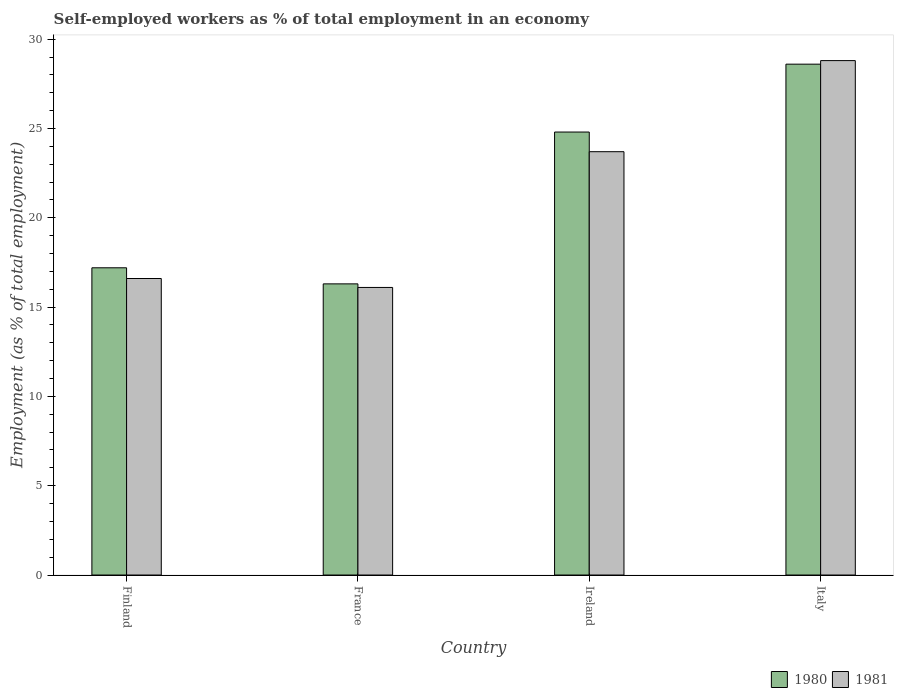How many bars are there on the 2nd tick from the left?
Make the answer very short. 2. How many bars are there on the 1st tick from the right?
Your response must be concise. 2. What is the label of the 3rd group of bars from the left?
Provide a short and direct response. Ireland. In how many cases, is the number of bars for a given country not equal to the number of legend labels?
Provide a succinct answer. 0. What is the percentage of self-employed workers in 1980 in Italy?
Make the answer very short. 28.6. Across all countries, what is the maximum percentage of self-employed workers in 1980?
Ensure brevity in your answer.  28.6. Across all countries, what is the minimum percentage of self-employed workers in 1980?
Your answer should be very brief. 16.3. In which country was the percentage of self-employed workers in 1980 maximum?
Keep it short and to the point. Italy. In which country was the percentage of self-employed workers in 1980 minimum?
Offer a terse response. France. What is the total percentage of self-employed workers in 1980 in the graph?
Provide a succinct answer. 86.9. What is the difference between the percentage of self-employed workers in 1981 in Finland and that in Ireland?
Your answer should be very brief. -7.1. What is the difference between the percentage of self-employed workers in 1981 in Ireland and the percentage of self-employed workers in 1980 in Finland?
Keep it short and to the point. 6.5. What is the average percentage of self-employed workers in 1980 per country?
Your answer should be compact. 21.72. What is the difference between the percentage of self-employed workers of/in 1980 and percentage of self-employed workers of/in 1981 in France?
Your answer should be compact. 0.2. In how many countries, is the percentage of self-employed workers in 1980 greater than 13 %?
Provide a short and direct response. 4. What is the ratio of the percentage of self-employed workers in 1980 in Finland to that in Italy?
Your response must be concise. 0.6. What is the difference between the highest and the second highest percentage of self-employed workers in 1980?
Offer a terse response. 7.6. What is the difference between the highest and the lowest percentage of self-employed workers in 1980?
Your answer should be compact. 12.3. In how many countries, is the percentage of self-employed workers in 1981 greater than the average percentage of self-employed workers in 1981 taken over all countries?
Make the answer very short. 2. What does the 2nd bar from the left in Ireland represents?
Give a very brief answer. 1981. What does the 2nd bar from the right in Ireland represents?
Your answer should be compact. 1980. How many countries are there in the graph?
Make the answer very short. 4. What is the difference between two consecutive major ticks on the Y-axis?
Your answer should be very brief. 5. Are the values on the major ticks of Y-axis written in scientific E-notation?
Keep it short and to the point. No. Does the graph contain any zero values?
Keep it short and to the point. No. Where does the legend appear in the graph?
Provide a succinct answer. Bottom right. How are the legend labels stacked?
Make the answer very short. Horizontal. What is the title of the graph?
Your answer should be compact. Self-employed workers as % of total employment in an economy. What is the label or title of the X-axis?
Offer a very short reply. Country. What is the label or title of the Y-axis?
Make the answer very short. Employment (as % of total employment). What is the Employment (as % of total employment) in 1980 in Finland?
Make the answer very short. 17.2. What is the Employment (as % of total employment) of 1981 in Finland?
Offer a very short reply. 16.6. What is the Employment (as % of total employment) in 1980 in France?
Ensure brevity in your answer.  16.3. What is the Employment (as % of total employment) of 1981 in France?
Keep it short and to the point. 16.1. What is the Employment (as % of total employment) of 1980 in Ireland?
Give a very brief answer. 24.8. What is the Employment (as % of total employment) of 1981 in Ireland?
Offer a terse response. 23.7. What is the Employment (as % of total employment) of 1980 in Italy?
Provide a succinct answer. 28.6. What is the Employment (as % of total employment) of 1981 in Italy?
Your answer should be very brief. 28.8. Across all countries, what is the maximum Employment (as % of total employment) in 1980?
Provide a short and direct response. 28.6. Across all countries, what is the maximum Employment (as % of total employment) of 1981?
Offer a terse response. 28.8. Across all countries, what is the minimum Employment (as % of total employment) in 1980?
Offer a terse response. 16.3. Across all countries, what is the minimum Employment (as % of total employment) of 1981?
Give a very brief answer. 16.1. What is the total Employment (as % of total employment) in 1980 in the graph?
Your answer should be very brief. 86.9. What is the total Employment (as % of total employment) in 1981 in the graph?
Your answer should be very brief. 85.2. What is the difference between the Employment (as % of total employment) of 1980 in Finland and that in France?
Offer a very short reply. 0.9. What is the difference between the Employment (as % of total employment) in 1981 in Finland and that in France?
Offer a very short reply. 0.5. What is the difference between the Employment (as % of total employment) of 1980 in Finland and that in Ireland?
Give a very brief answer. -7.6. What is the difference between the Employment (as % of total employment) in 1980 in Finland and that in Italy?
Offer a terse response. -11.4. What is the difference between the Employment (as % of total employment) in 1981 in Finland and that in Italy?
Ensure brevity in your answer.  -12.2. What is the difference between the Employment (as % of total employment) in 1980 in France and that in Ireland?
Your response must be concise. -8.5. What is the difference between the Employment (as % of total employment) in 1981 in Ireland and that in Italy?
Your response must be concise. -5.1. What is the difference between the Employment (as % of total employment) in 1980 in Finland and the Employment (as % of total employment) in 1981 in Ireland?
Your answer should be compact. -6.5. What is the difference between the Employment (as % of total employment) of 1980 in France and the Employment (as % of total employment) of 1981 in Italy?
Make the answer very short. -12.5. What is the average Employment (as % of total employment) of 1980 per country?
Provide a succinct answer. 21.73. What is the average Employment (as % of total employment) in 1981 per country?
Your response must be concise. 21.3. What is the difference between the Employment (as % of total employment) of 1980 and Employment (as % of total employment) of 1981 in France?
Give a very brief answer. 0.2. What is the ratio of the Employment (as % of total employment) in 1980 in Finland to that in France?
Your answer should be very brief. 1.06. What is the ratio of the Employment (as % of total employment) in 1981 in Finland to that in France?
Provide a short and direct response. 1.03. What is the ratio of the Employment (as % of total employment) of 1980 in Finland to that in Ireland?
Provide a short and direct response. 0.69. What is the ratio of the Employment (as % of total employment) in 1981 in Finland to that in Ireland?
Offer a very short reply. 0.7. What is the ratio of the Employment (as % of total employment) in 1980 in Finland to that in Italy?
Offer a very short reply. 0.6. What is the ratio of the Employment (as % of total employment) of 1981 in Finland to that in Italy?
Your response must be concise. 0.58. What is the ratio of the Employment (as % of total employment) of 1980 in France to that in Ireland?
Provide a short and direct response. 0.66. What is the ratio of the Employment (as % of total employment) of 1981 in France to that in Ireland?
Offer a very short reply. 0.68. What is the ratio of the Employment (as % of total employment) of 1980 in France to that in Italy?
Make the answer very short. 0.57. What is the ratio of the Employment (as % of total employment) of 1981 in France to that in Italy?
Give a very brief answer. 0.56. What is the ratio of the Employment (as % of total employment) of 1980 in Ireland to that in Italy?
Make the answer very short. 0.87. What is the ratio of the Employment (as % of total employment) in 1981 in Ireland to that in Italy?
Ensure brevity in your answer.  0.82. What is the difference between the highest and the second highest Employment (as % of total employment) in 1980?
Provide a short and direct response. 3.8. 